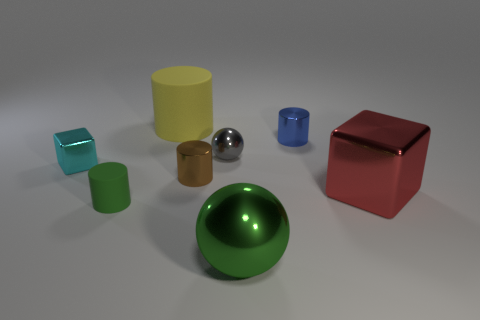Are there any other big brown objects of the same shape as the brown metallic object?
Provide a succinct answer. No. Does the big rubber object have the same color as the small sphere?
Offer a very short reply. No. What is the material of the block to the left of the cylinder right of the green metallic ball?
Provide a short and direct response. Metal. The yellow matte cylinder is what size?
Your answer should be compact. Large. There is a brown thing that is made of the same material as the gray thing; what size is it?
Provide a succinct answer. Small. Is the size of the rubber cylinder behind the green rubber cylinder the same as the small blue metal cylinder?
Give a very brief answer. No. There is a matte thing in front of the cube to the left of the sphere behind the cyan metal object; what shape is it?
Provide a succinct answer. Cylinder. How many things are small matte cylinders or objects in front of the big yellow cylinder?
Offer a terse response. 7. There is a ball that is left of the big green sphere; how big is it?
Offer a terse response. Small. There is a rubber thing that is the same color as the large shiny sphere; what shape is it?
Offer a very short reply. Cylinder. 